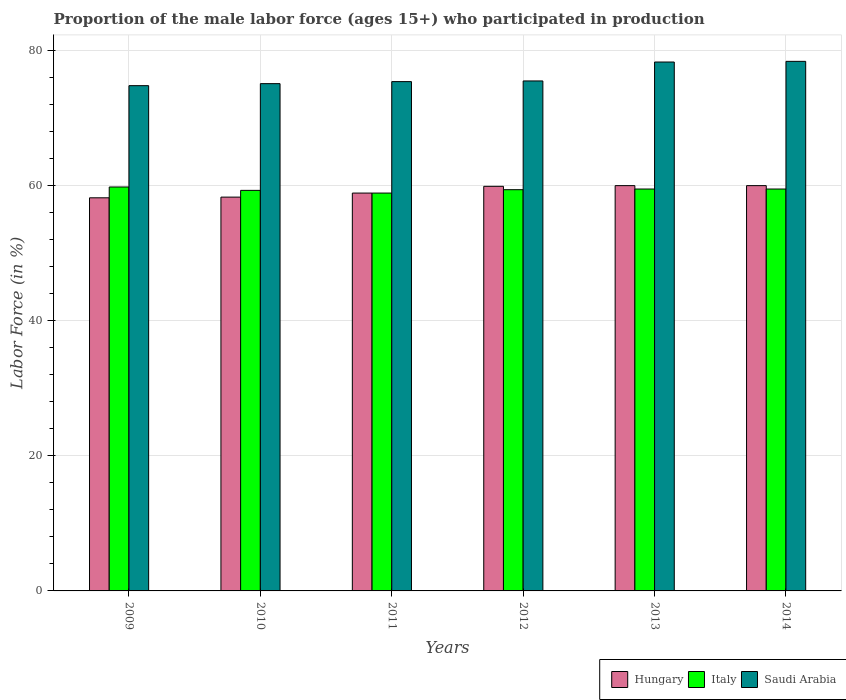How many different coloured bars are there?
Give a very brief answer. 3. How many groups of bars are there?
Your response must be concise. 6. How many bars are there on the 4th tick from the left?
Provide a short and direct response. 3. What is the label of the 6th group of bars from the left?
Your response must be concise. 2014. Across all years, what is the maximum proportion of the male labor force who participated in production in Saudi Arabia?
Your response must be concise. 78.4. Across all years, what is the minimum proportion of the male labor force who participated in production in Hungary?
Provide a short and direct response. 58.2. In which year was the proportion of the male labor force who participated in production in Saudi Arabia maximum?
Keep it short and to the point. 2014. What is the total proportion of the male labor force who participated in production in Saudi Arabia in the graph?
Provide a short and direct response. 457.5. What is the difference between the proportion of the male labor force who participated in production in Italy in 2010 and that in 2014?
Your response must be concise. -0.2. What is the difference between the proportion of the male labor force who participated in production in Saudi Arabia in 2009 and the proportion of the male labor force who participated in production in Italy in 2012?
Your answer should be very brief. 15.4. What is the average proportion of the male labor force who participated in production in Hungary per year?
Your answer should be very brief. 59.22. In the year 2014, what is the difference between the proportion of the male labor force who participated in production in Hungary and proportion of the male labor force who participated in production in Italy?
Provide a succinct answer. 0.5. In how many years, is the proportion of the male labor force who participated in production in Hungary greater than 48 %?
Offer a terse response. 6. What is the ratio of the proportion of the male labor force who participated in production in Hungary in 2010 to that in 2013?
Keep it short and to the point. 0.97. Is the proportion of the male labor force who participated in production in Italy in 2009 less than that in 2011?
Your answer should be compact. No. What is the difference between the highest and the second highest proportion of the male labor force who participated in production in Hungary?
Provide a succinct answer. 0. What is the difference between the highest and the lowest proportion of the male labor force who participated in production in Saudi Arabia?
Make the answer very short. 3.6. What does the 3rd bar from the left in 2010 represents?
Keep it short and to the point. Saudi Arabia. What does the 3rd bar from the right in 2009 represents?
Provide a succinct answer. Hungary. Is it the case that in every year, the sum of the proportion of the male labor force who participated in production in Hungary and proportion of the male labor force who participated in production in Italy is greater than the proportion of the male labor force who participated in production in Saudi Arabia?
Provide a succinct answer. Yes. How many bars are there?
Your answer should be compact. 18. Does the graph contain any zero values?
Keep it short and to the point. No. What is the title of the graph?
Give a very brief answer. Proportion of the male labor force (ages 15+) who participated in production. Does "Madagascar" appear as one of the legend labels in the graph?
Provide a succinct answer. No. What is the label or title of the X-axis?
Ensure brevity in your answer.  Years. What is the Labor Force (in %) of Hungary in 2009?
Offer a terse response. 58.2. What is the Labor Force (in %) in Italy in 2009?
Keep it short and to the point. 59.8. What is the Labor Force (in %) in Saudi Arabia in 2009?
Offer a very short reply. 74.8. What is the Labor Force (in %) of Hungary in 2010?
Your answer should be compact. 58.3. What is the Labor Force (in %) in Italy in 2010?
Your response must be concise. 59.3. What is the Labor Force (in %) in Saudi Arabia in 2010?
Give a very brief answer. 75.1. What is the Labor Force (in %) in Hungary in 2011?
Offer a terse response. 58.9. What is the Labor Force (in %) in Italy in 2011?
Provide a succinct answer. 58.9. What is the Labor Force (in %) in Saudi Arabia in 2011?
Your answer should be very brief. 75.4. What is the Labor Force (in %) in Hungary in 2012?
Ensure brevity in your answer.  59.9. What is the Labor Force (in %) of Italy in 2012?
Give a very brief answer. 59.4. What is the Labor Force (in %) in Saudi Arabia in 2012?
Ensure brevity in your answer.  75.5. What is the Labor Force (in %) of Italy in 2013?
Offer a very short reply. 59.5. What is the Labor Force (in %) in Saudi Arabia in 2013?
Ensure brevity in your answer.  78.3. What is the Labor Force (in %) in Hungary in 2014?
Provide a short and direct response. 60. What is the Labor Force (in %) in Italy in 2014?
Give a very brief answer. 59.5. What is the Labor Force (in %) in Saudi Arabia in 2014?
Offer a terse response. 78.4. Across all years, what is the maximum Labor Force (in %) in Hungary?
Your answer should be very brief. 60. Across all years, what is the maximum Labor Force (in %) in Italy?
Provide a succinct answer. 59.8. Across all years, what is the maximum Labor Force (in %) of Saudi Arabia?
Offer a very short reply. 78.4. Across all years, what is the minimum Labor Force (in %) of Hungary?
Give a very brief answer. 58.2. Across all years, what is the minimum Labor Force (in %) of Italy?
Keep it short and to the point. 58.9. Across all years, what is the minimum Labor Force (in %) in Saudi Arabia?
Offer a terse response. 74.8. What is the total Labor Force (in %) in Hungary in the graph?
Provide a succinct answer. 355.3. What is the total Labor Force (in %) of Italy in the graph?
Keep it short and to the point. 356.4. What is the total Labor Force (in %) of Saudi Arabia in the graph?
Your response must be concise. 457.5. What is the difference between the Labor Force (in %) of Italy in 2009 and that in 2010?
Your answer should be compact. 0.5. What is the difference between the Labor Force (in %) in Hungary in 2009 and that in 2013?
Make the answer very short. -1.8. What is the difference between the Labor Force (in %) in Italy in 2009 and that in 2013?
Your response must be concise. 0.3. What is the difference between the Labor Force (in %) in Italy in 2009 and that in 2014?
Provide a succinct answer. 0.3. What is the difference between the Labor Force (in %) of Hungary in 2010 and that in 2011?
Your response must be concise. -0.6. What is the difference between the Labor Force (in %) in Hungary in 2010 and that in 2012?
Offer a very short reply. -1.6. What is the difference between the Labor Force (in %) in Italy in 2010 and that in 2012?
Provide a short and direct response. -0.1. What is the difference between the Labor Force (in %) in Saudi Arabia in 2010 and that in 2012?
Keep it short and to the point. -0.4. What is the difference between the Labor Force (in %) in Saudi Arabia in 2010 and that in 2013?
Offer a terse response. -3.2. What is the difference between the Labor Force (in %) in Hungary in 2010 and that in 2014?
Your answer should be compact. -1.7. What is the difference between the Labor Force (in %) in Italy in 2010 and that in 2014?
Offer a very short reply. -0.2. What is the difference between the Labor Force (in %) in Italy in 2011 and that in 2012?
Your response must be concise. -0.5. What is the difference between the Labor Force (in %) in Saudi Arabia in 2011 and that in 2012?
Offer a very short reply. -0.1. What is the difference between the Labor Force (in %) of Italy in 2011 and that in 2013?
Offer a terse response. -0.6. What is the difference between the Labor Force (in %) of Saudi Arabia in 2011 and that in 2013?
Your answer should be very brief. -2.9. What is the difference between the Labor Force (in %) in Hungary in 2011 and that in 2014?
Provide a short and direct response. -1.1. What is the difference between the Labor Force (in %) of Italy in 2012 and that in 2013?
Make the answer very short. -0.1. What is the difference between the Labor Force (in %) of Italy in 2012 and that in 2014?
Give a very brief answer. -0.1. What is the difference between the Labor Force (in %) in Saudi Arabia in 2012 and that in 2014?
Your answer should be compact. -2.9. What is the difference between the Labor Force (in %) of Italy in 2013 and that in 2014?
Provide a succinct answer. 0. What is the difference between the Labor Force (in %) of Saudi Arabia in 2013 and that in 2014?
Give a very brief answer. -0.1. What is the difference between the Labor Force (in %) in Hungary in 2009 and the Labor Force (in %) in Italy in 2010?
Your response must be concise. -1.1. What is the difference between the Labor Force (in %) of Hungary in 2009 and the Labor Force (in %) of Saudi Arabia in 2010?
Keep it short and to the point. -16.9. What is the difference between the Labor Force (in %) of Italy in 2009 and the Labor Force (in %) of Saudi Arabia in 2010?
Keep it short and to the point. -15.3. What is the difference between the Labor Force (in %) of Hungary in 2009 and the Labor Force (in %) of Italy in 2011?
Your answer should be compact. -0.7. What is the difference between the Labor Force (in %) of Hungary in 2009 and the Labor Force (in %) of Saudi Arabia in 2011?
Provide a short and direct response. -17.2. What is the difference between the Labor Force (in %) of Italy in 2009 and the Labor Force (in %) of Saudi Arabia in 2011?
Your answer should be compact. -15.6. What is the difference between the Labor Force (in %) of Hungary in 2009 and the Labor Force (in %) of Saudi Arabia in 2012?
Your answer should be compact. -17.3. What is the difference between the Labor Force (in %) of Italy in 2009 and the Labor Force (in %) of Saudi Arabia in 2012?
Your answer should be compact. -15.7. What is the difference between the Labor Force (in %) in Hungary in 2009 and the Labor Force (in %) in Italy in 2013?
Keep it short and to the point. -1.3. What is the difference between the Labor Force (in %) in Hungary in 2009 and the Labor Force (in %) in Saudi Arabia in 2013?
Offer a very short reply. -20.1. What is the difference between the Labor Force (in %) in Italy in 2009 and the Labor Force (in %) in Saudi Arabia in 2013?
Offer a terse response. -18.5. What is the difference between the Labor Force (in %) of Hungary in 2009 and the Labor Force (in %) of Italy in 2014?
Keep it short and to the point. -1.3. What is the difference between the Labor Force (in %) in Hungary in 2009 and the Labor Force (in %) in Saudi Arabia in 2014?
Give a very brief answer. -20.2. What is the difference between the Labor Force (in %) of Italy in 2009 and the Labor Force (in %) of Saudi Arabia in 2014?
Provide a short and direct response. -18.6. What is the difference between the Labor Force (in %) of Hungary in 2010 and the Labor Force (in %) of Italy in 2011?
Your answer should be compact. -0.6. What is the difference between the Labor Force (in %) of Hungary in 2010 and the Labor Force (in %) of Saudi Arabia in 2011?
Offer a very short reply. -17.1. What is the difference between the Labor Force (in %) of Italy in 2010 and the Labor Force (in %) of Saudi Arabia in 2011?
Offer a very short reply. -16.1. What is the difference between the Labor Force (in %) in Hungary in 2010 and the Labor Force (in %) in Italy in 2012?
Ensure brevity in your answer.  -1.1. What is the difference between the Labor Force (in %) in Hungary in 2010 and the Labor Force (in %) in Saudi Arabia in 2012?
Ensure brevity in your answer.  -17.2. What is the difference between the Labor Force (in %) of Italy in 2010 and the Labor Force (in %) of Saudi Arabia in 2012?
Provide a short and direct response. -16.2. What is the difference between the Labor Force (in %) of Hungary in 2010 and the Labor Force (in %) of Italy in 2013?
Offer a terse response. -1.2. What is the difference between the Labor Force (in %) in Italy in 2010 and the Labor Force (in %) in Saudi Arabia in 2013?
Make the answer very short. -19. What is the difference between the Labor Force (in %) in Hungary in 2010 and the Labor Force (in %) in Saudi Arabia in 2014?
Offer a very short reply. -20.1. What is the difference between the Labor Force (in %) in Italy in 2010 and the Labor Force (in %) in Saudi Arabia in 2014?
Give a very brief answer. -19.1. What is the difference between the Labor Force (in %) in Hungary in 2011 and the Labor Force (in %) in Saudi Arabia in 2012?
Give a very brief answer. -16.6. What is the difference between the Labor Force (in %) in Italy in 2011 and the Labor Force (in %) in Saudi Arabia in 2012?
Make the answer very short. -16.6. What is the difference between the Labor Force (in %) in Hungary in 2011 and the Labor Force (in %) in Italy in 2013?
Offer a very short reply. -0.6. What is the difference between the Labor Force (in %) of Hungary in 2011 and the Labor Force (in %) of Saudi Arabia in 2013?
Give a very brief answer. -19.4. What is the difference between the Labor Force (in %) in Italy in 2011 and the Labor Force (in %) in Saudi Arabia in 2013?
Ensure brevity in your answer.  -19.4. What is the difference between the Labor Force (in %) of Hungary in 2011 and the Labor Force (in %) of Saudi Arabia in 2014?
Your response must be concise. -19.5. What is the difference between the Labor Force (in %) in Italy in 2011 and the Labor Force (in %) in Saudi Arabia in 2014?
Give a very brief answer. -19.5. What is the difference between the Labor Force (in %) in Hungary in 2012 and the Labor Force (in %) in Italy in 2013?
Your response must be concise. 0.4. What is the difference between the Labor Force (in %) of Hungary in 2012 and the Labor Force (in %) of Saudi Arabia in 2013?
Offer a terse response. -18.4. What is the difference between the Labor Force (in %) in Italy in 2012 and the Labor Force (in %) in Saudi Arabia in 2013?
Your response must be concise. -18.9. What is the difference between the Labor Force (in %) in Hungary in 2012 and the Labor Force (in %) in Italy in 2014?
Provide a succinct answer. 0.4. What is the difference between the Labor Force (in %) of Hungary in 2012 and the Labor Force (in %) of Saudi Arabia in 2014?
Your answer should be very brief. -18.5. What is the difference between the Labor Force (in %) in Italy in 2012 and the Labor Force (in %) in Saudi Arabia in 2014?
Your answer should be very brief. -19. What is the difference between the Labor Force (in %) in Hungary in 2013 and the Labor Force (in %) in Italy in 2014?
Provide a succinct answer. 0.5. What is the difference between the Labor Force (in %) in Hungary in 2013 and the Labor Force (in %) in Saudi Arabia in 2014?
Ensure brevity in your answer.  -18.4. What is the difference between the Labor Force (in %) of Italy in 2013 and the Labor Force (in %) of Saudi Arabia in 2014?
Keep it short and to the point. -18.9. What is the average Labor Force (in %) of Hungary per year?
Your answer should be compact. 59.22. What is the average Labor Force (in %) in Italy per year?
Keep it short and to the point. 59.4. What is the average Labor Force (in %) in Saudi Arabia per year?
Your answer should be very brief. 76.25. In the year 2009, what is the difference between the Labor Force (in %) in Hungary and Labor Force (in %) in Italy?
Your answer should be compact. -1.6. In the year 2009, what is the difference between the Labor Force (in %) of Hungary and Labor Force (in %) of Saudi Arabia?
Keep it short and to the point. -16.6. In the year 2010, what is the difference between the Labor Force (in %) of Hungary and Labor Force (in %) of Saudi Arabia?
Offer a very short reply. -16.8. In the year 2010, what is the difference between the Labor Force (in %) of Italy and Labor Force (in %) of Saudi Arabia?
Your answer should be very brief. -15.8. In the year 2011, what is the difference between the Labor Force (in %) in Hungary and Labor Force (in %) in Saudi Arabia?
Keep it short and to the point. -16.5. In the year 2011, what is the difference between the Labor Force (in %) in Italy and Labor Force (in %) in Saudi Arabia?
Provide a succinct answer. -16.5. In the year 2012, what is the difference between the Labor Force (in %) of Hungary and Labor Force (in %) of Italy?
Provide a succinct answer. 0.5. In the year 2012, what is the difference between the Labor Force (in %) in Hungary and Labor Force (in %) in Saudi Arabia?
Provide a short and direct response. -15.6. In the year 2012, what is the difference between the Labor Force (in %) of Italy and Labor Force (in %) of Saudi Arabia?
Offer a terse response. -16.1. In the year 2013, what is the difference between the Labor Force (in %) in Hungary and Labor Force (in %) in Saudi Arabia?
Give a very brief answer. -18.3. In the year 2013, what is the difference between the Labor Force (in %) of Italy and Labor Force (in %) of Saudi Arabia?
Provide a succinct answer. -18.8. In the year 2014, what is the difference between the Labor Force (in %) of Hungary and Labor Force (in %) of Italy?
Provide a short and direct response. 0.5. In the year 2014, what is the difference between the Labor Force (in %) in Hungary and Labor Force (in %) in Saudi Arabia?
Keep it short and to the point. -18.4. In the year 2014, what is the difference between the Labor Force (in %) of Italy and Labor Force (in %) of Saudi Arabia?
Offer a very short reply. -18.9. What is the ratio of the Labor Force (in %) of Italy in 2009 to that in 2010?
Ensure brevity in your answer.  1.01. What is the ratio of the Labor Force (in %) in Hungary in 2009 to that in 2011?
Give a very brief answer. 0.99. What is the ratio of the Labor Force (in %) in Italy in 2009 to that in 2011?
Your answer should be very brief. 1.02. What is the ratio of the Labor Force (in %) of Hungary in 2009 to that in 2012?
Your answer should be compact. 0.97. What is the ratio of the Labor Force (in %) in Italy in 2009 to that in 2012?
Your response must be concise. 1.01. What is the ratio of the Labor Force (in %) of Saudi Arabia in 2009 to that in 2012?
Keep it short and to the point. 0.99. What is the ratio of the Labor Force (in %) in Hungary in 2009 to that in 2013?
Ensure brevity in your answer.  0.97. What is the ratio of the Labor Force (in %) in Saudi Arabia in 2009 to that in 2013?
Offer a very short reply. 0.96. What is the ratio of the Labor Force (in %) of Italy in 2009 to that in 2014?
Provide a succinct answer. 1. What is the ratio of the Labor Force (in %) of Saudi Arabia in 2009 to that in 2014?
Make the answer very short. 0.95. What is the ratio of the Labor Force (in %) in Hungary in 2010 to that in 2011?
Provide a short and direct response. 0.99. What is the ratio of the Labor Force (in %) in Italy in 2010 to that in 2011?
Your answer should be compact. 1.01. What is the ratio of the Labor Force (in %) of Saudi Arabia in 2010 to that in 2011?
Provide a short and direct response. 1. What is the ratio of the Labor Force (in %) in Hungary in 2010 to that in 2012?
Provide a succinct answer. 0.97. What is the ratio of the Labor Force (in %) in Hungary in 2010 to that in 2013?
Your answer should be very brief. 0.97. What is the ratio of the Labor Force (in %) in Italy in 2010 to that in 2013?
Your response must be concise. 1. What is the ratio of the Labor Force (in %) in Saudi Arabia in 2010 to that in 2013?
Provide a succinct answer. 0.96. What is the ratio of the Labor Force (in %) of Hungary in 2010 to that in 2014?
Keep it short and to the point. 0.97. What is the ratio of the Labor Force (in %) of Saudi Arabia in 2010 to that in 2014?
Offer a terse response. 0.96. What is the ratio of the Labor Force (in %) of Hungary in 2011 to that in 2012?
Make the answer very short. 0.98. What is the ratio of the Labor Force (in %) of Italy in 2011 to that in 2012?
Give a very brief answer. 0.99. What is the ratio of the Labor Force (in %) of Hungary in 2011 to that in 2013?
Offer a very short reply. 0.98. What is the ratio of the Labor Force (in %) in Italy in 2011 to that in 2013?
Your answer should be very brief. 0.99. What is the ratio of the Labor Force (in %) in Saudi Arabia in 2011 to that in 2013?
Give a very brief answer. 0.96. What is the ratio of the Labor Force (in %) of Hungary in 2011 to that in 2014?
Your answer should be compact. 0.98. What is the ratio of the Labor Force (in %) of Saudi Arabia in 2011 to that in 2014?
Make the answer very short. 0.96. What is the ratio of the Labor Force (in %) in Hungary in 2012 to that in 2013?
Make the answer very short. 1. What is the ratio of the Labor Force (in %) of Italy in 2012 to that in 2013?
Offer a very short reply. 1. What is the ratio of the Labor Force (in %) of Saudi Arabia in 2012 to that in 2013?
Keep it short and to the point. 0.96. What is the ratio of the Labor Force (in %) of Hungary in 2013 to that in 2014?
Offer a very short reply. 1. What is the ratio of the Labor Force (in %) of Italy in 2013 to that in 2014?
Offer a very short reply. 1. What is the difference between the highest and the second highest Labor Force (in %) in Saudi Arabia?
Give a very brief answer. 0.1. What is the difference between the highest and the lowest Labor Force (in %) of Italy?
Keep it short and to the point. 0.9. What is the difference between the highest and the lowest Labor Force (in %) in Saudi Arabia?
Offer a terse response. 3.6. 